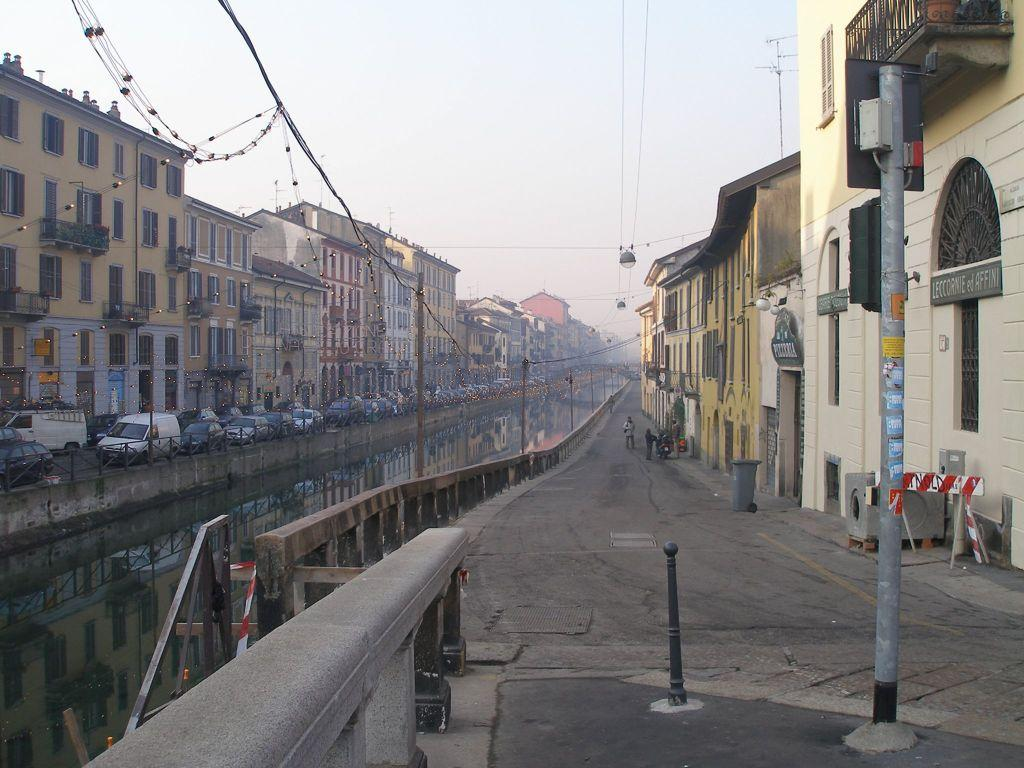What can be seen on the road in the image? There are vehicles on the road in the image. What objects are present in the image besides the vehicles? There are poles, boards, wires, lights, and buildings in the image. What is visible in the background of the image? The sky is visible in the background of the image. Can you see the thrill of the foot race happening in the image? There is no foot race present in the image; it features vehicles on the road, poles, boards, wires, lights, buildings, and the sky. 